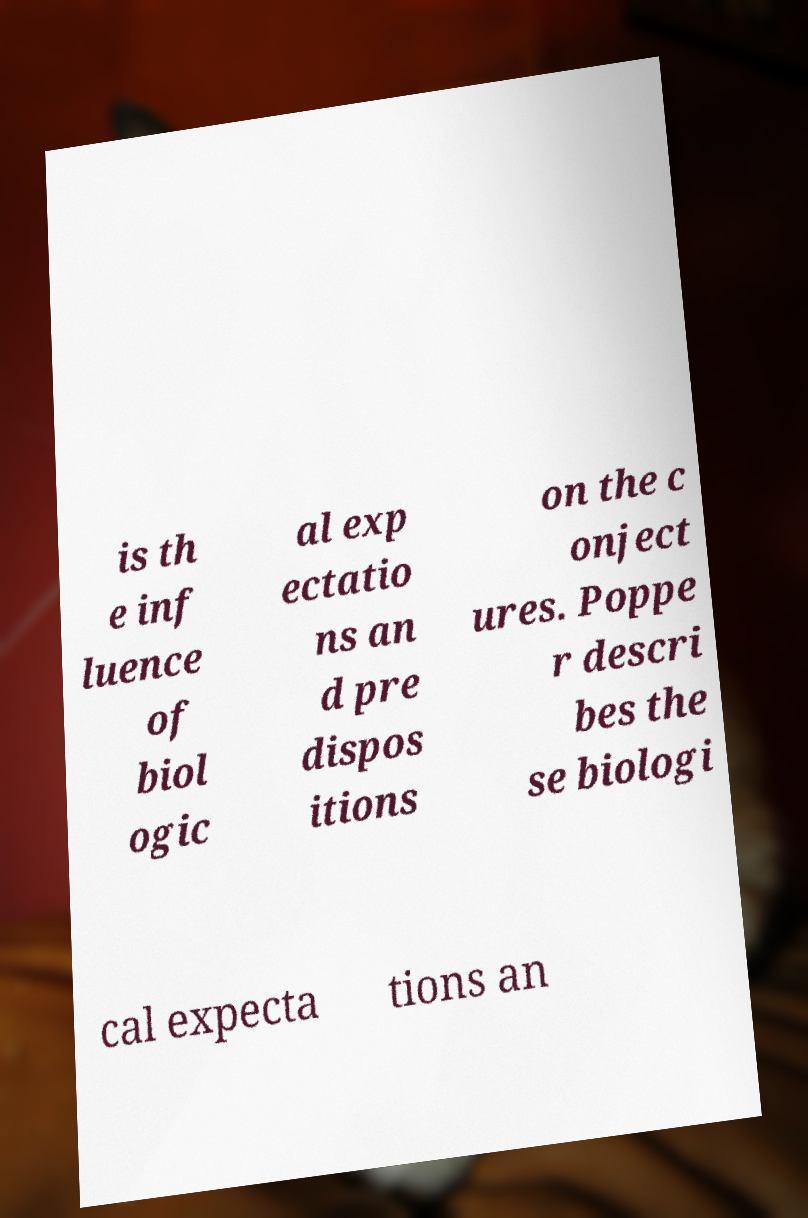Could you assist in decoding the text presented in this image and type it out clearly? is th e inf luence of biol ogic al exp ectatio ns an d pre dispos itions on the c onject ures. Poppe r descri bes the se biologi cal expecta tions an 